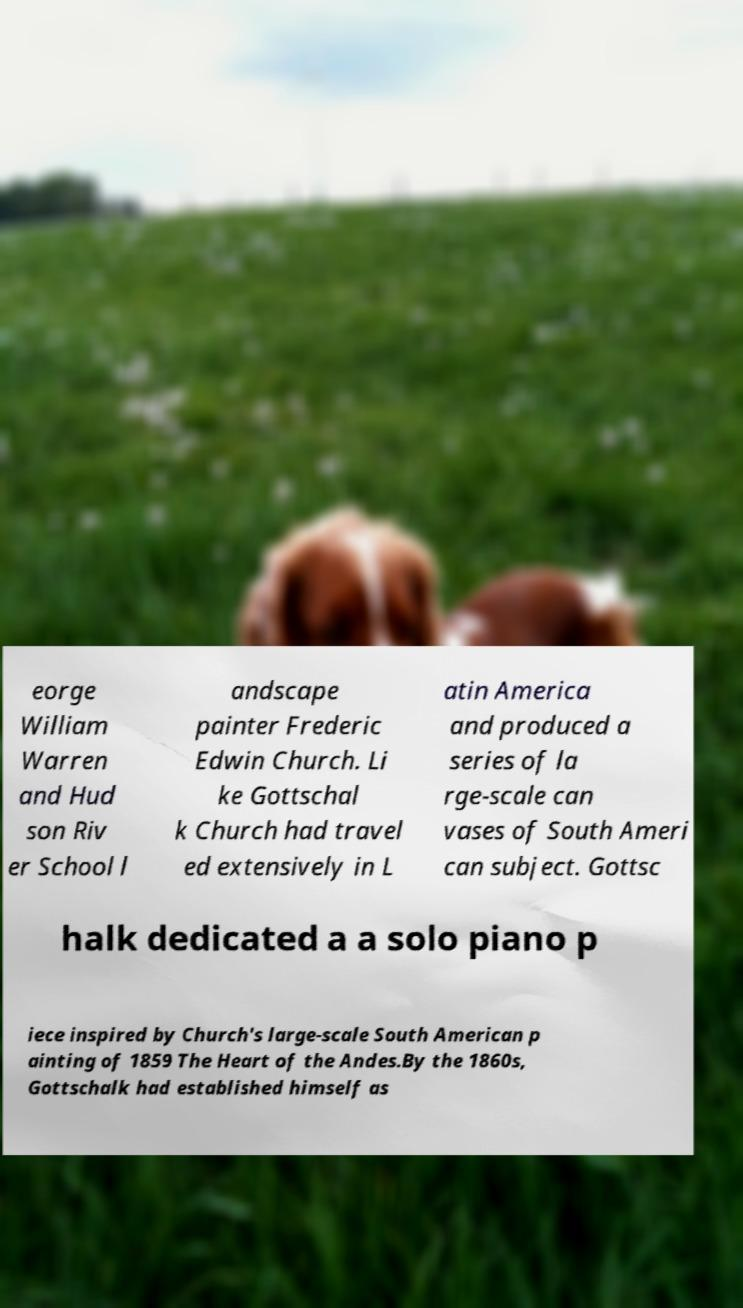For documentation purposes, I need the text within this image transcribed. Could you provide that? eorge William Warren and Hud son Riv er School l andscape painter Frederic Edwin Church. Li ke Gottschal k Church had travel ed extensively in L atin America and produced a series of la rge-scale can vases of South Ameri can subject. Gottsc halk dedicated a a solo piano p iece inspired by Church's large-scale South American p ainting of 1859 The Heart of the Andes.By the 1860s, Gottschalk had established himself as 